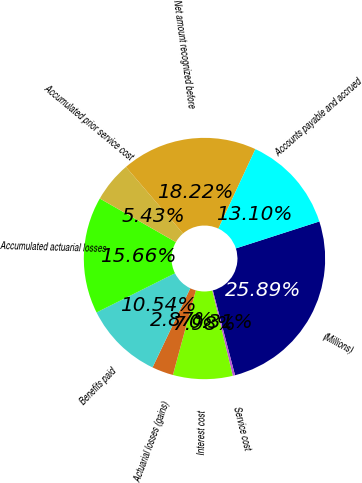<chart> <loc_0><loc_0><loc_500><loc_500><pie_chart><fcel>(Millions)<fcel>Service cost<fcel>Interest cost<fcel>Actuarial losses (gains)<fcel>Benefits paid<fcel>Accumulated actuarial losses<fcel>Accumulated prior service cost<fcel>Net amount recognized before<fcel>Accounts payable and accrued<nl><fcel>25.89%<fcel>0.31%<fcel>7.98%<fcel>2.87%<fcel>10.54%<fcel>15.66%<fcel>5.43%<fcel>18.22%<fcel>13.1%<nl></chart> 